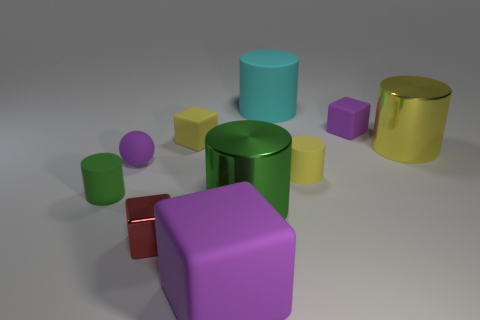Subtract all cyan cylinders. How many cylinders are left? 4 Subtract all large rubber cylinders. How many cylinders are left? 4 Subtract all gray cylinders. Subtract all cyan balls. How many cylinders are left? 5 Subtract all spheres. How many objects are left? 9 Subtract 0 brown cubes. How many objects are left? 10 Subtract all brown metal cylinders. Subtract all yellow metallic cylinders. How many objects are left? 9 Add 4 large cyan rubber cylinders. How many large cyan rubber cylinders are left? 5 Add 3 purple rubber objects. How many purple rubber objects exist? 6 